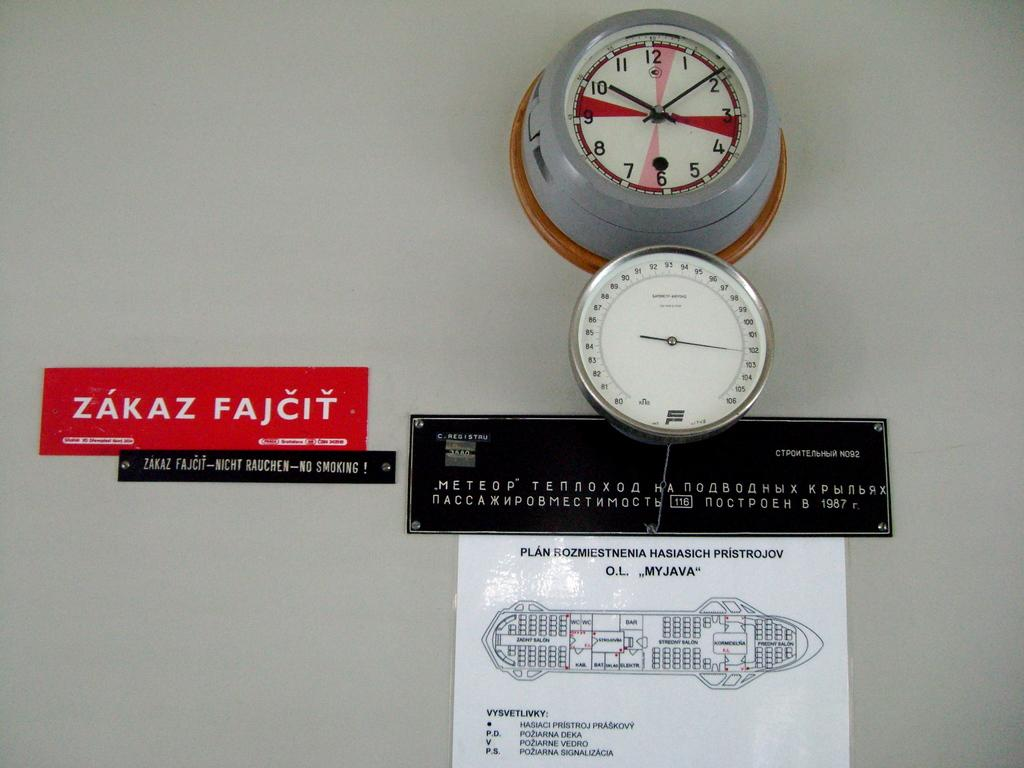<image>
Give a short and clear explanation of the subsequent image. A clock, meter, map, and sign with the words "ZAKAZ" on it. 